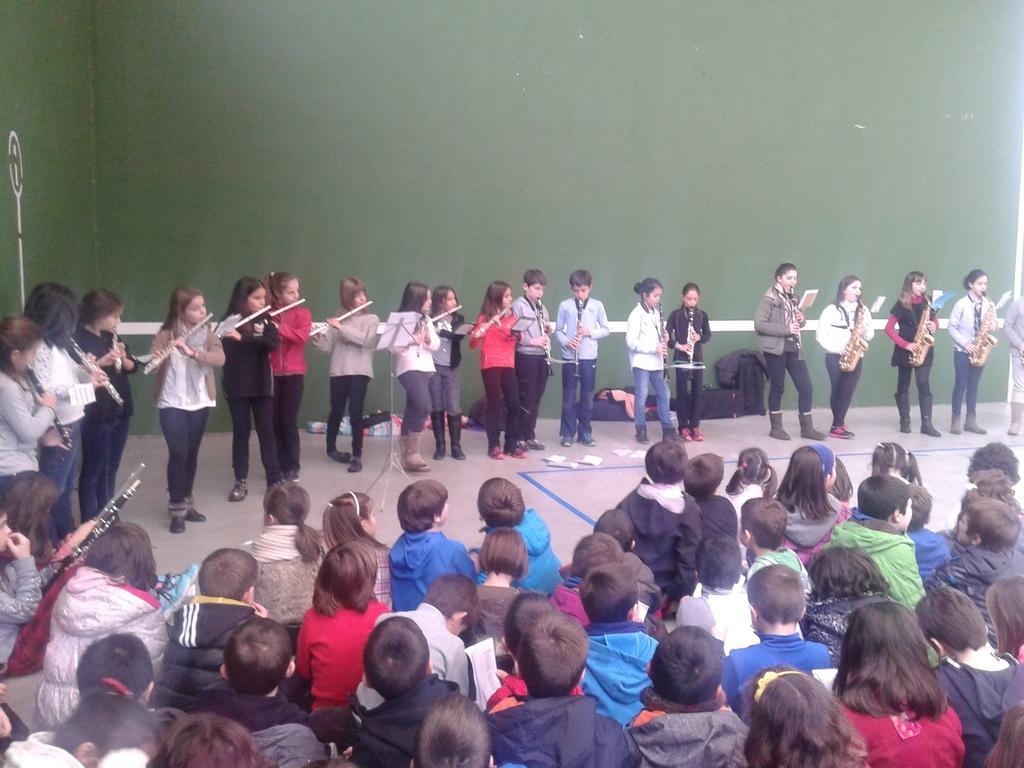Describe this image in one or two sentences. In the center of the image we can see a group of people are standing and holding musical instruments. In the center of the image we can see a stand and book. At the bottom of the image we can see a group of people are sitting. In the background of the image we can see the wall and bags. In the middle of the image we can see the floor and papers. 